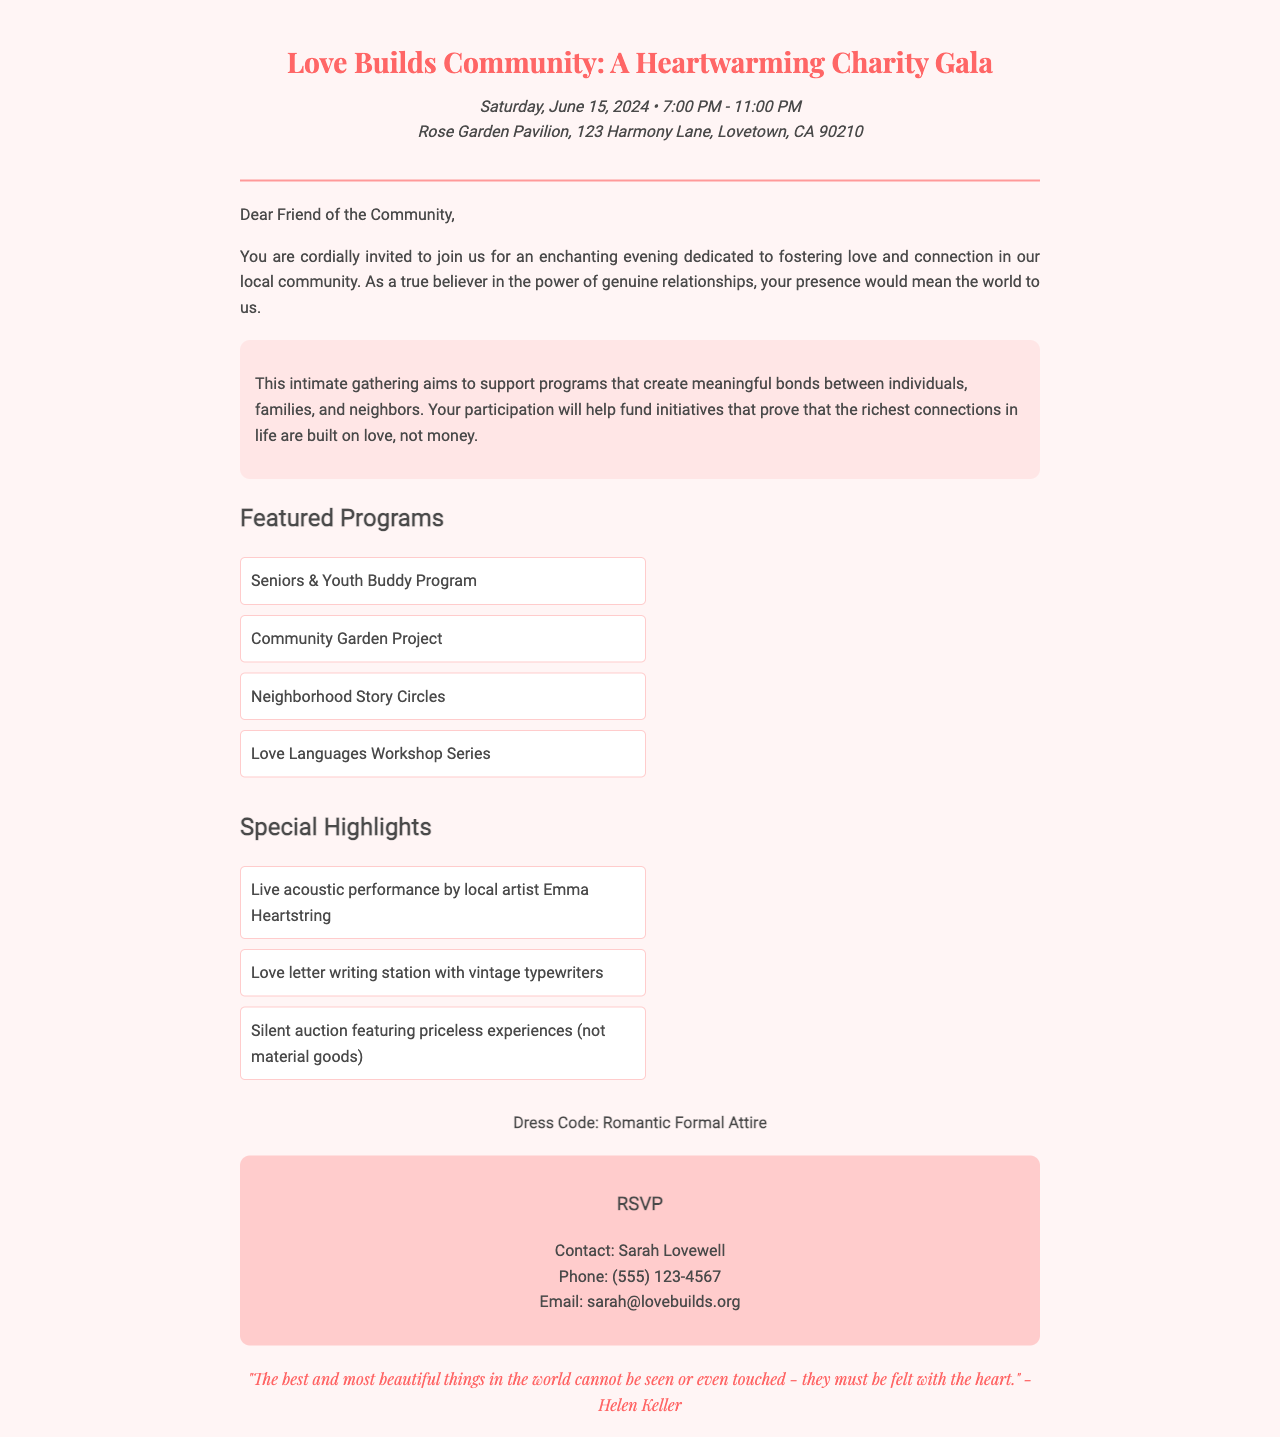What is the title of the event? The title of the event is prominently displayed at the top of the document.
Answer: Love Builds Community: A Heartwarming Charity Gala What is the date of the event? The date of the event is specified in the date-time-venue section of the document.
Answer: Saturday, June 15, 2024 What time does the event start? The start time is included in the date-time-venue section of the document.
Answer: 7:00 PM Where is the event being held? The location is clearly stated in the date-time-venue section of the document.
Answer: Rose Garden Pavilion, 123 Harmony Lane, Lovetown, CA 90210 Who should be contacted for RSVP? The RSVP information section provides the contact person's name.
Answer: Sarah Lovewell What type of attire is requested? The document specifies the dress code toward the end.
Answer: Romantic Formal Attire What is one featured program listed? The featured programs are enumerated, and one example will be a valid answer.
Answer: Seniors & Youth Buddy Program What is the special highlight involving live entertainment? The document describes one of the special highlights with live performance details.
Answer: Live acoustic performance by local artist Emma Heartstring What does the quote at the bottom of the document emphasize? The footer quote conveys a sentiment that relates to love and feelings.
Answer: The best and most beautiful things in the world cannot be seen or even touched - they must be felt with the heart What does the event aim to support? The event description explains the purpose of the gathering regarding community support.
Answer: Programs that create meaningful bonds between individuals, families, and neighbors 